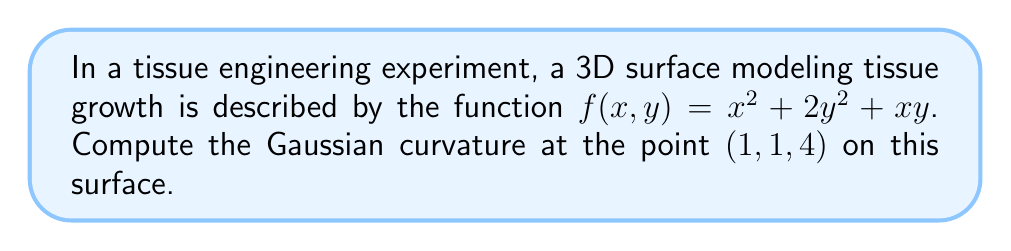Help me with this question. To compute the Gaussian curvature of the given 3D surface, we'll follow these steps:

1) The Gaussian curvature K is given by:

   $$K = \frac{LN - M^2}{EG - F^2}$$

   where L, M, N are coefficients of the second fundamental form, and E, F, G are coefficients of the first fundamental form.

2) First, we need to calculate the partial derivatives:

   $$f_x = 2x + y$$
   $$f_y = 4y + x$$
   $$f_{xx} = 2$$
   $$f_{xy} = f_{yx} = 1$$
   $$f_{yy} = 4$$

3) Now, we can calculate E, F, and G:

   $$E = 1 + f_x^2 = 1 + (2x + y)^2$$
   $$F = f_x f_y = (2x + y)(4y + x)$$
   $$G = 1 + f_y^2 = 1 + (4y + x)^2$$

4) Next, we calculate the unit normal vector:

   $$\vec{N} = \frac{(-f_x, -f_y, 1)}{\sqrt{1 + f_x^2 + f_y^2}}$$

5) Now we can calculate L, M, and N:

   $$L = \frac{f_{xx}}{\sqrt{1 + f_x^2 + f_y^2}} = \frac{2}{\sqrt{1 + (2x + y)^2 + (4y + x)^2}}$$
   
   $$M = \frac{f_{xy}}{\sqrt{1 + f_x^2 + f_y^2}} = \frac{1}{\sqrt{1 + (2x + y)^2 + (4y + x)^2}}$$
   
   $$N = \frac{f_{yy}}{\sqrt{1 + f_x^2 + f_y^2}} = \frac{4}{\sqrt{1 + (2x + y)^2 + (4y + x)^2}}$$

6) At the point (1,1,4), we have:

   $$E = 1 + (2(1) + 1)^2 = 10$$
   $$F = (2(1) + 1)(4(1) + 1) = 15$$
   $$G = 1 + (4(1) + 1)^2 = 26$$
   $$L = \frac{2}{\sqrt{1 + 3^2 + 5^2}} = \frac{2}{\sqrt{35}}$$
   $$M = \frac{1}{\sqrt{35}}$$
   $$N = \frac{4}{\sqrt{35}}$$

7) Finally, we can calculate the Gaussian curvature:

   $$K = \frac{LN - M^2}{EG - F^2} = \frac{(\frac{2}{\sqrt{35}})(\frac{4}{\sqrt{35}}) - (\frac{1}{\sqrt{35}})^2}{(10)(26) - 15^2}$$

   $$= \frac{\frac{8}{35} - \frac{1}{35}}{260 - 225} = \frac{\frac{7}{35}}{35} = \frac{1}{175}$$
Answer: $\frac{1}{175}$ 